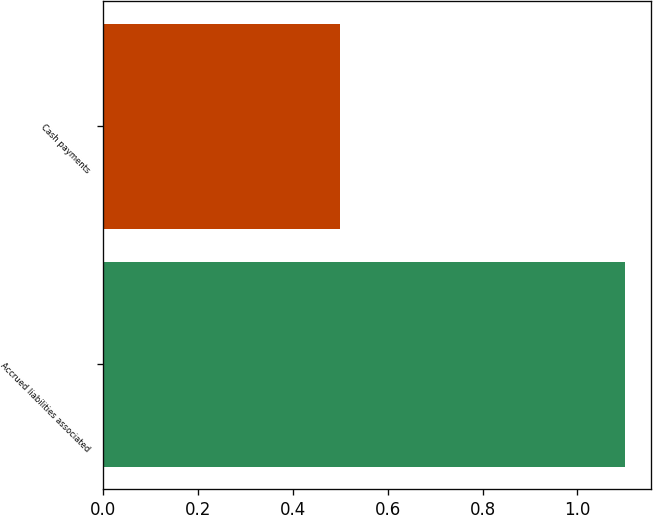Convert chart to OTSL. <chart><loc_0><loc_0><loc_500><loc_500><bar_chart><fcel>Accrued liabilities associated<fcel>Cash payments<nl><fcel>1.1<fcel>0.5<nl></chart> 